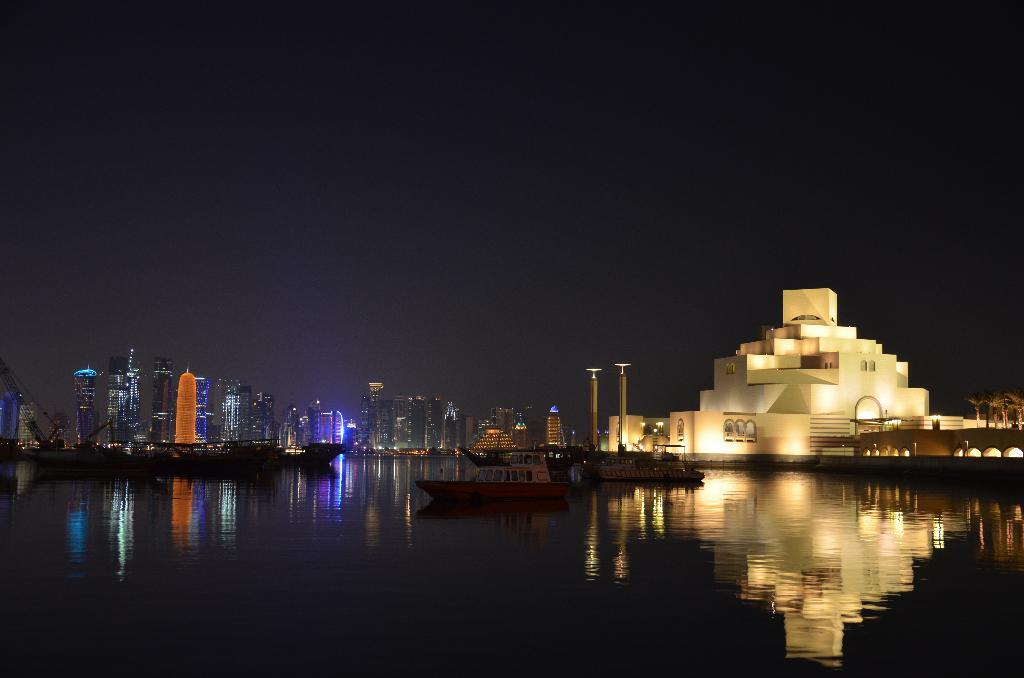What is happening with the boats in the image? The boats are above the water in the image. What structures can be seen in the image? Poles and architecture are visible in the image. What can be seen in the background of the image? There are buildings, lights, and the sky visible in the background of the image. What type of reaction can be seen from the money in the image? There is no money present in the image, so no reaction can be observed. 